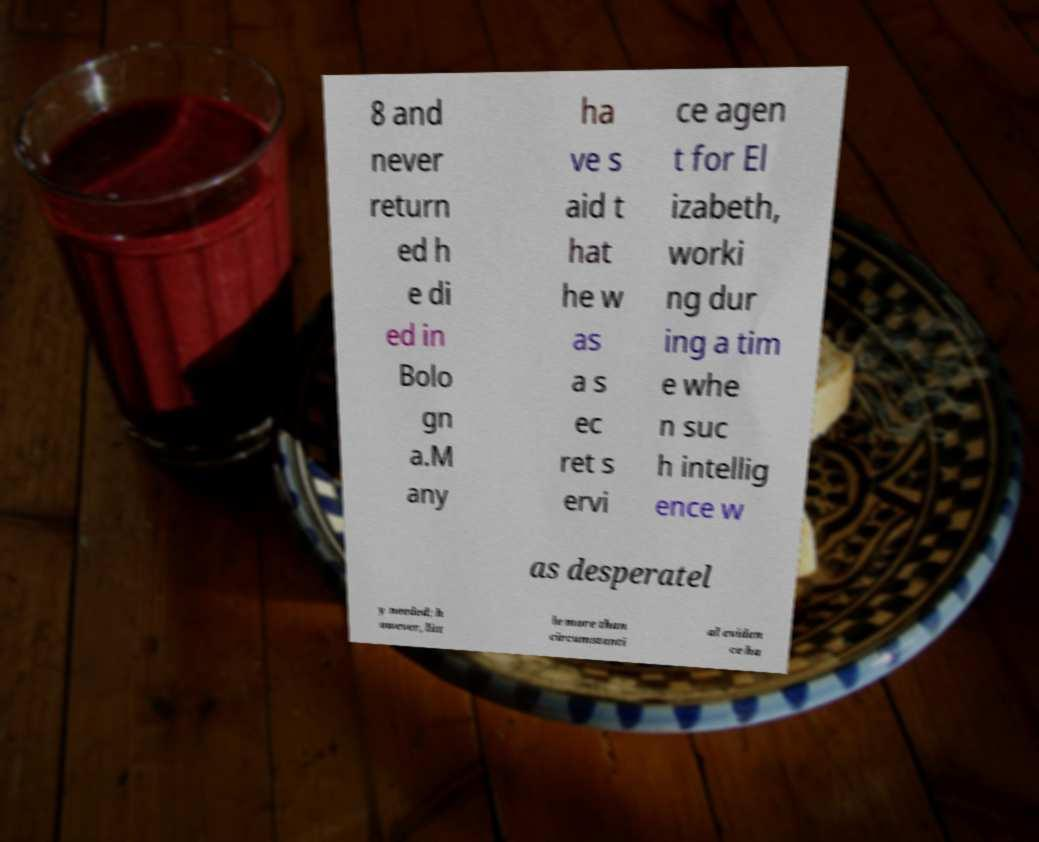What messages or text are displayed in this image? I need them in a readable, typed format. 8 and never return ed h e di ed in Bolo gn a.M any ha ve s aid t hat he w as a s ec ret s ervi ce agen t for El izabeth, worki ng dur ing a tim e whe n suc h intellig ence w as desperatel y needed; h owever, litt le more than circumstanti al eviden ce ha 